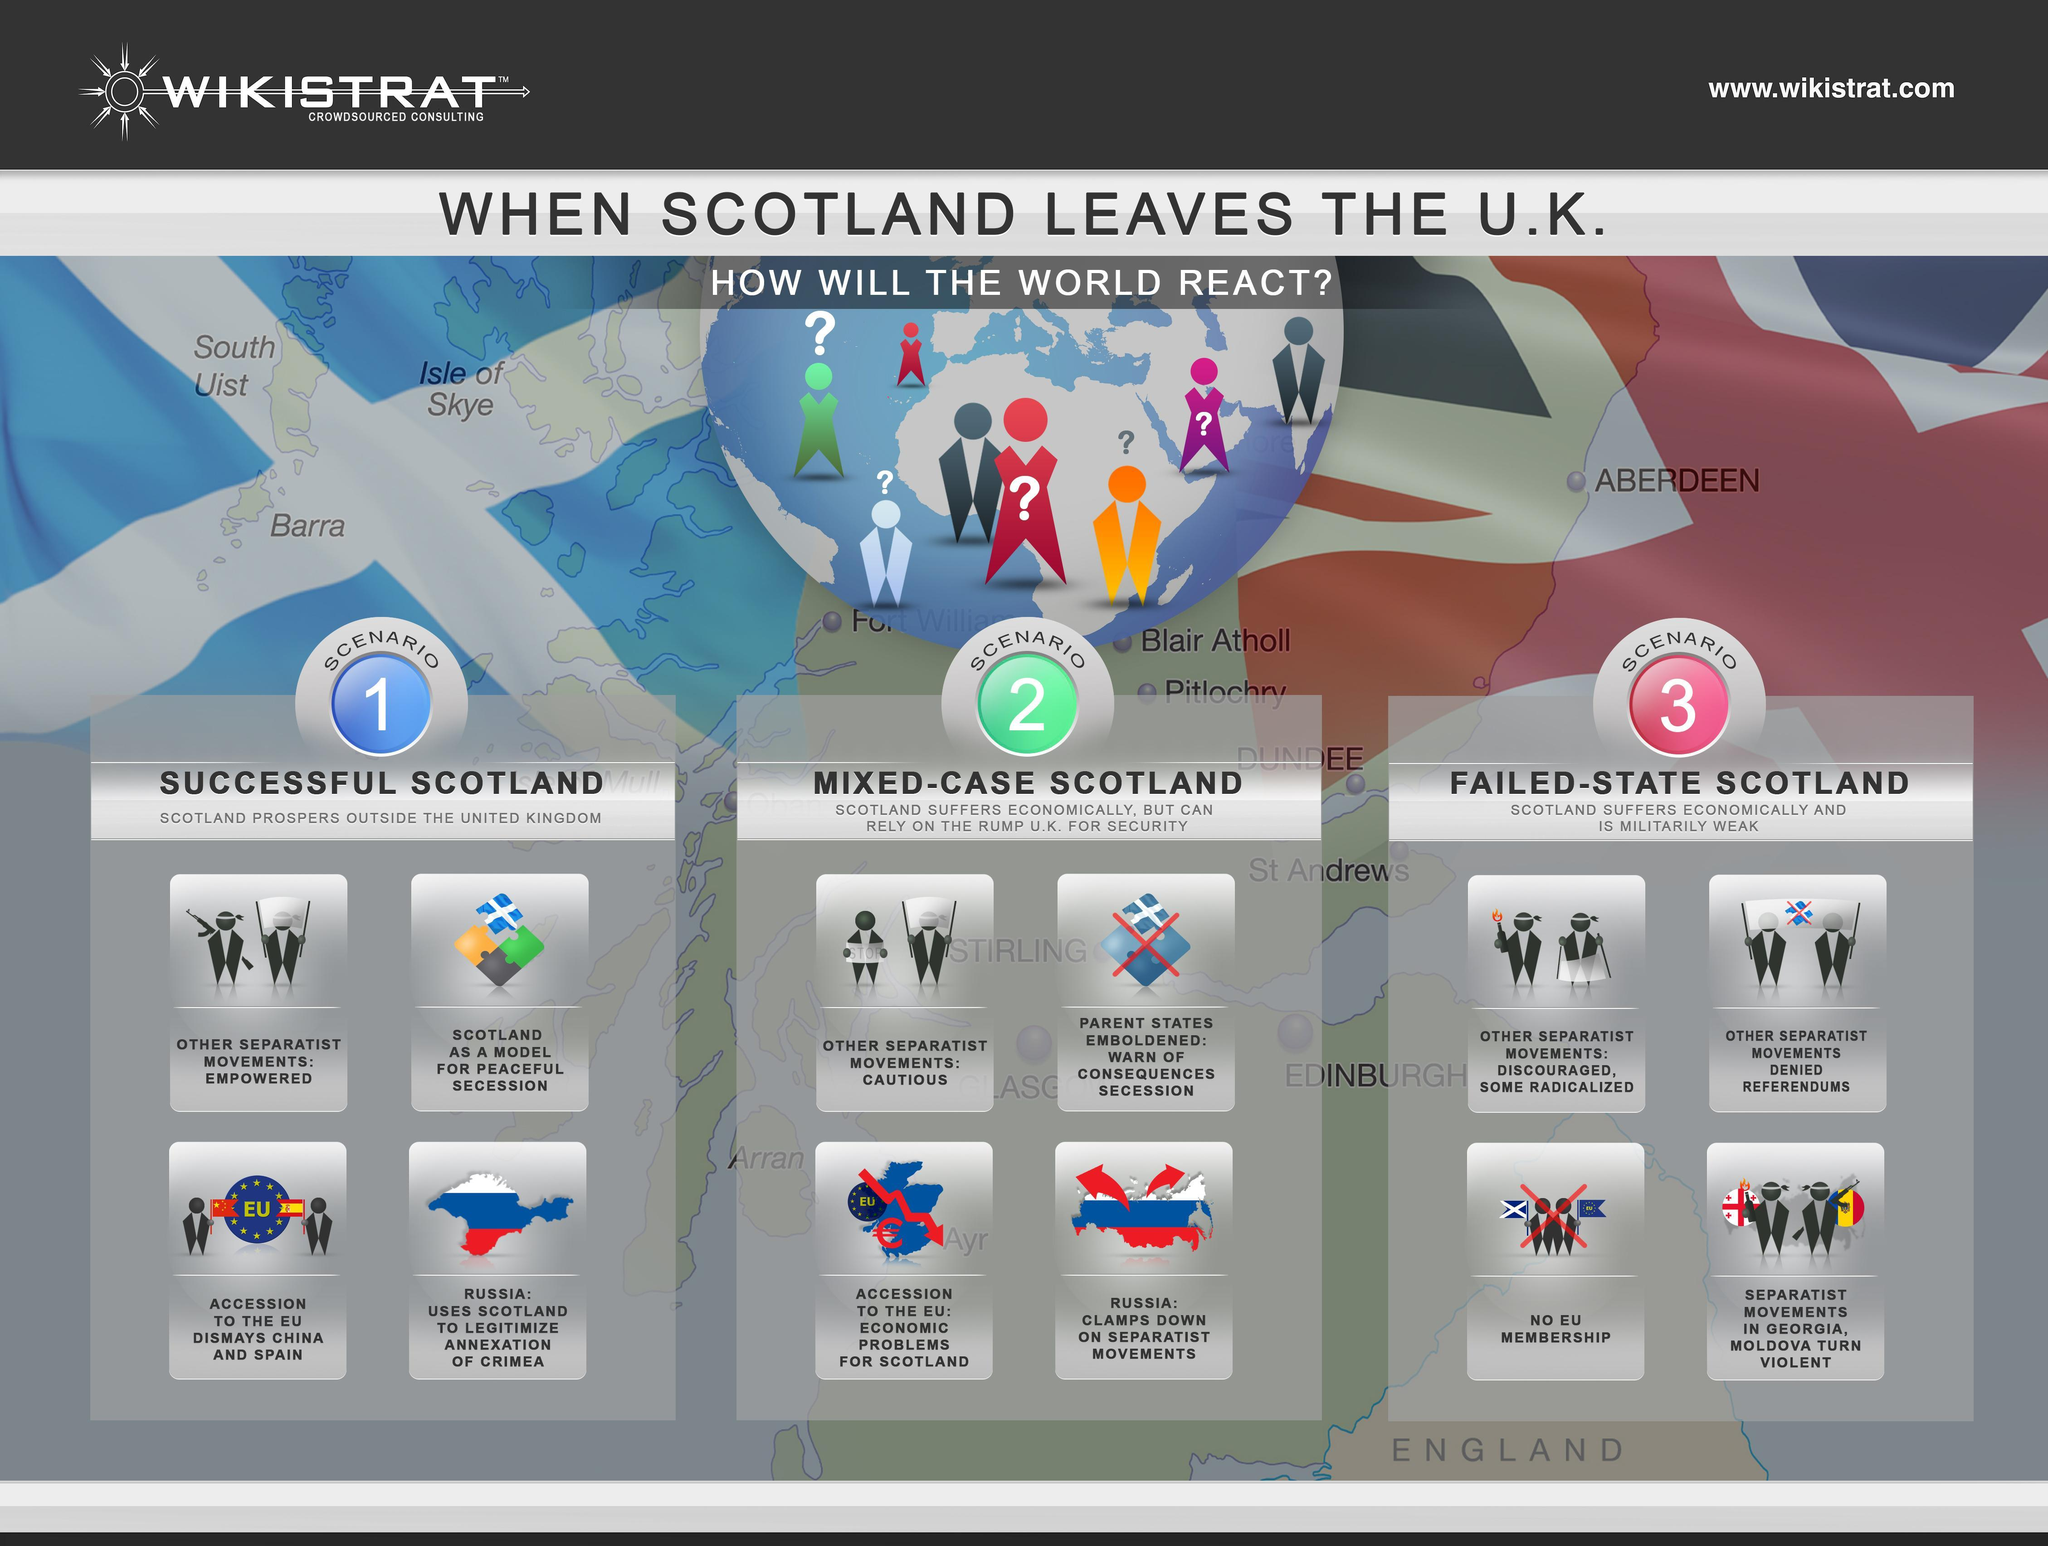In which scenario do the other separatist movements are empowered?
Answer the question with a short phrase. Successful Scotland In which scenario Scotland will suffer economically 1, 2 or 3? 2,3 